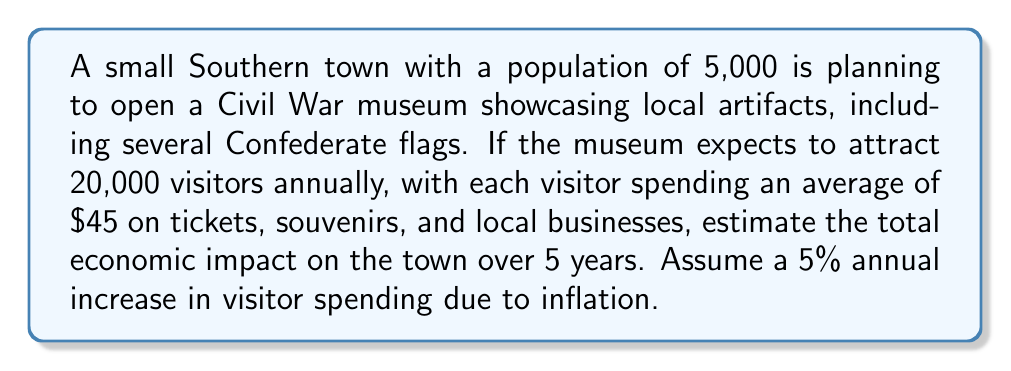Solve this math problem. Let's break this down step-by-step:

1) First, calculate the initial annual economic impact:
   $20,000 \text{ visitors} \times \$45 \text{ per visitor} = \$900,000$

2) Now, we need to account for the 5% annual increase in spending:
   Year 1: $\$900,000$
   Year 2: $\$900,000 \times 1.05 = \$945,000$
   Year 3: $\$945,000 \times 1.05 = \$992,250$
   Year 4: $\$992,250 \times 1.05 = \$1,041,862.50$
   Year 5: $\$1,041,862.50 \times 1.05 = \$1,093,955.63$

3) To find the total economic impact, sum up the impact for all 5 years:

   $$\sum_{i=1}^{5} 900000 \times (1.05)^{i-1}$$

   $= \$900,000 + \$945,000 + \$992,250 + \$1,041,862.50 + \$1,093,955.63$
   $= \$4,973,068.13$

Therefore, the estimated total economic impact over 5 years is approximately $4,973,068.13.
Answer: $4,973,068.13 